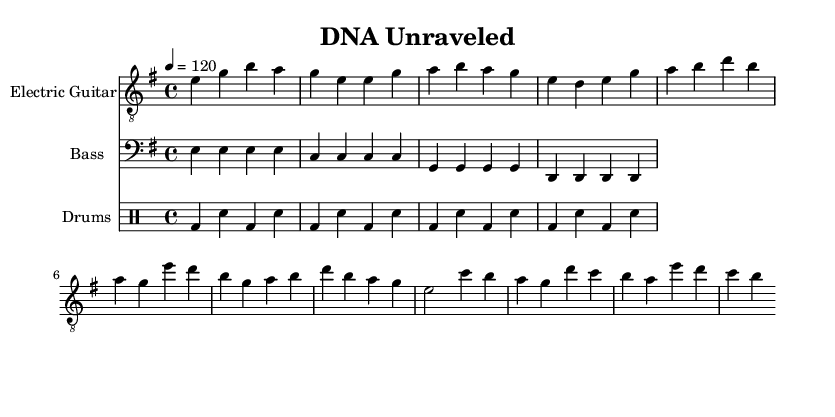What is the key signature of this music? The key signature is E minor, which contains one sharp (F#). This is indicated at the beginning of the staff where the sharps are shown.
Answer: E minor What is the time signature of this music? The time signature is 4/4, which is indicated at the beginning of the piece after the clef and key signature. This means there are four beats in a measure.
Answer: 4/4 What is the tempo indicated in the sheet music? The tempo is defined as quarter note equals 120 beats per minute, which is stated in the tempo marking at the top of the score.
Answer: 120 How many measures are in the electric guitar part? By counting the measures in the electric guitar staff, there are 8 measures. Each measure is separated by vertical lines in the score.
Answer: 8 What type of beat is primarily used in the drums part? The drums follow a basic rock beat, characterized by a kick drum and snare pattern that is steady and repetitive, typical in rock music.
Answer: Rock beat What is the root note played by the bass guitar in the first measure? The root note in the first measure of the bass guitar part is E, as indicated by the note positioned on the second line from the bottom in the bass clef.
Answer: E What type of instruments are included in this arrangement? The arrangement includes an electric guitar, bass guitar, and drums, which are typical instruments found in a rock band setup, as shown at the beginning of each staff.
Answer: Electric guitar, bass, drums 